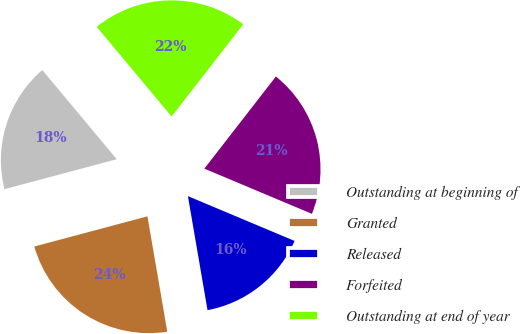<chart> <loc_0><loc_0><loc_500><loc_500><pie_chart><fcel>Outstanding at beginning of<fcel>Granted<fcel>Released<fcel>Forfeited<fcel>Outstanding at end of year<nl><fcel>18.08%<fcel>23.56%<fcel>15.96%<fcel>20.82%<fcel>21.58%<nl></chart> 